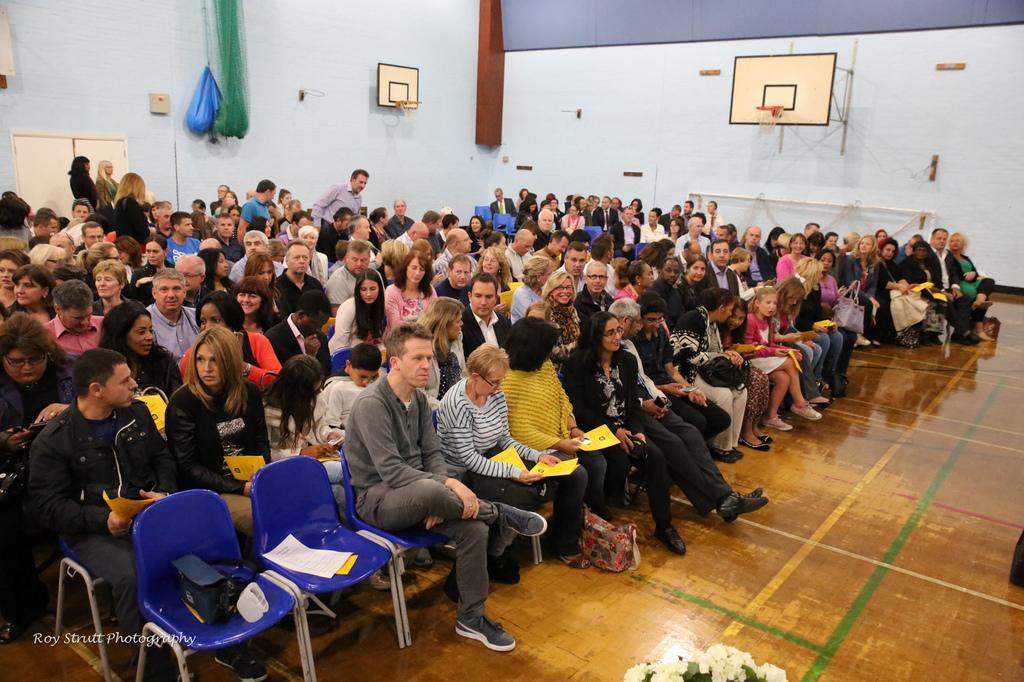How would you summarize this image in a sentence or two? This is a picture of a hall or a stadium where there are blue color chairs and a man sitting in the chair and there are some papers,bag etc.., in this chair and at the right side of this man there are woman who are sitting in this chair and at the right side of these people there are some group of people who are sitting and at the back ground there are so many group of people who are standing and sitting and to the wall there is a basketball court yard or a net attached to it , a door. 